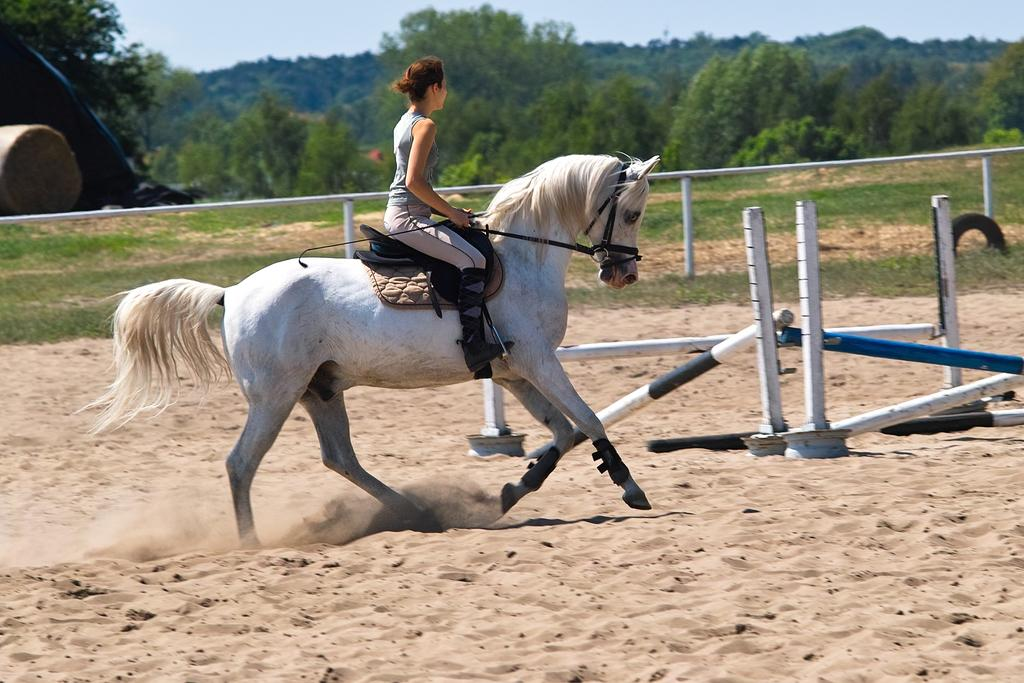What type of animal is in the image? There is a white horse in the image. Who is riding the horse? A woman is riding the horse. What can be seen in the background of the image? There are many trees and fencing visible in the background. What type of whistle can be heard during the meeting with the rabbits in the image? There is no whistle or meeting with rabbits present in the image. 